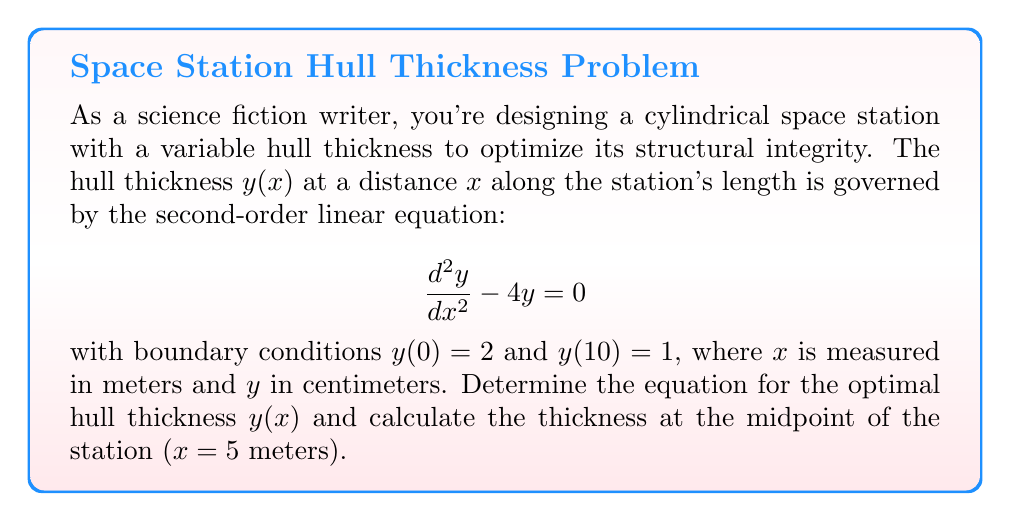Teach me how to tackle this problem. To solve this problem, we'll follow these steps:

1) The general solution to the given second-order linear equation is:

   $$y(x) = Ae^{2x} + Be^{-2x}$$

   where $A$ and $B$ are constants to be determined using the boundary conditions.

2) Apply the first boundary condition, $y(0) = 2$:

   $$2 = A + B$$

3) Apply the second boundary condition, $y(10) = 1$:

   $$1 = Ae^{20} + Be^{-20}$$

4) We now have a system of two equations with two unknowns:

   $$A + B = 2$$
   $$Ae^{20} + Be^{-20} = 1$$

5) Solve this system:
   - Multiply the first equation by $e^{20}$: $Ae^{20} + Be^{20} = 2e^{20}$
   - Subtract the second equation: $Be^{20} - Be^{-20} = 2e^{20} - 1$
   - Factor out $B$: $B(e^{20} - e^{-20}) = 2e^{20} - 1$
   - Solve for $B$: $B = \frac{2e^{20} - 1}{e^{20} - e^{-20}}$
   - Substitute this into $A + B = 2$ to find $A$

6) After calculations, we get:

   $$A \approx 0.00009095, B \approx 1.99990905$$

7) Therefore, the equation for the optimal hull thickness is:

   $$y(x) \approx 0.00009095e^{2x} + 1.99990905e^{-2x}$$

8) To find the thickness at the midpoint ($x = 5$), substitute $x = 5$ into this equation:

   $$y(5) \approx 0.00009095e^{10} + 1.99990905e^{-10}$$
Answer: The optimal hull thickness is given by:

$$y(x) \approx 0.00009095e^{2x} + 1.99990905e^{-2x}$$

The thickness at the midpoint ($x = 5$ meters) is approximately 1.34 cm. 